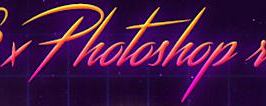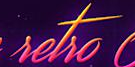Transcribe the words shown in these images in order, separated by a semicolon. Photoshop; setso 